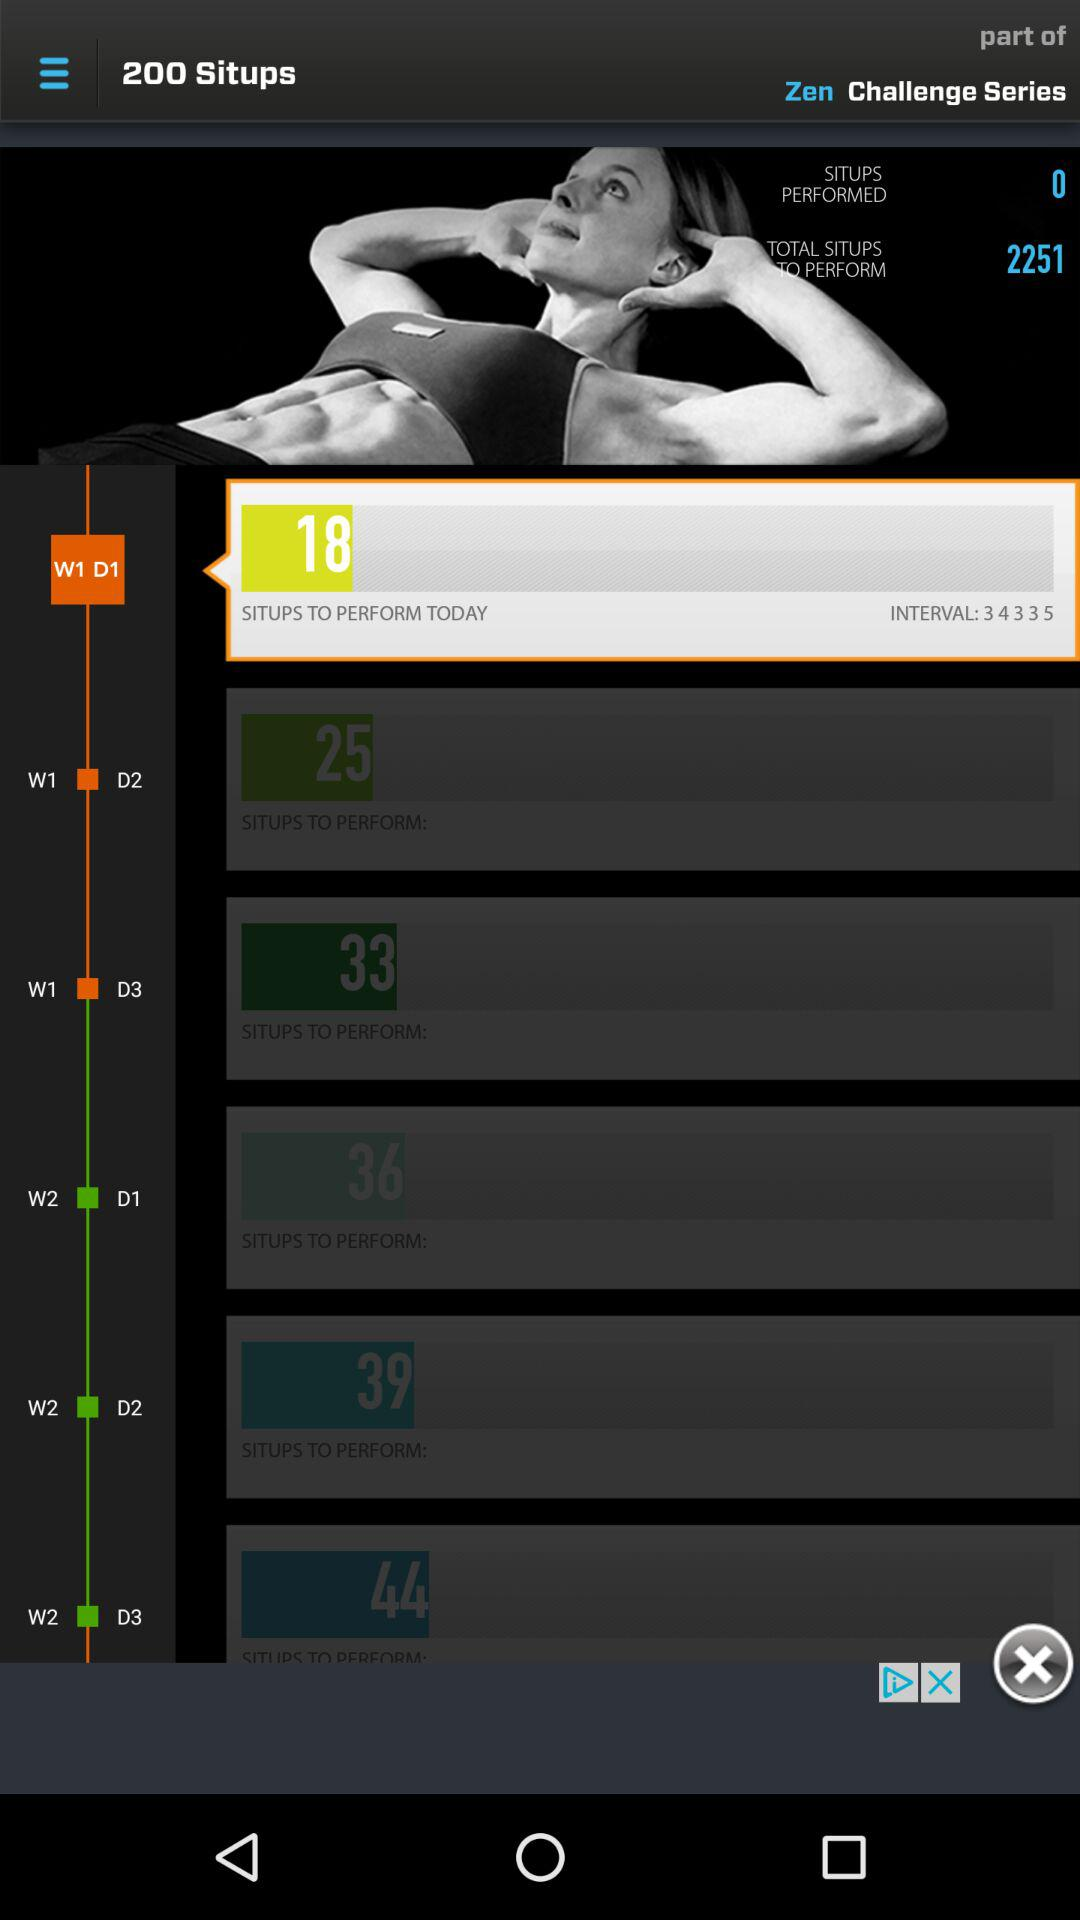How many sit-ups have performed till now? Sit-ups performed till now is 0. 